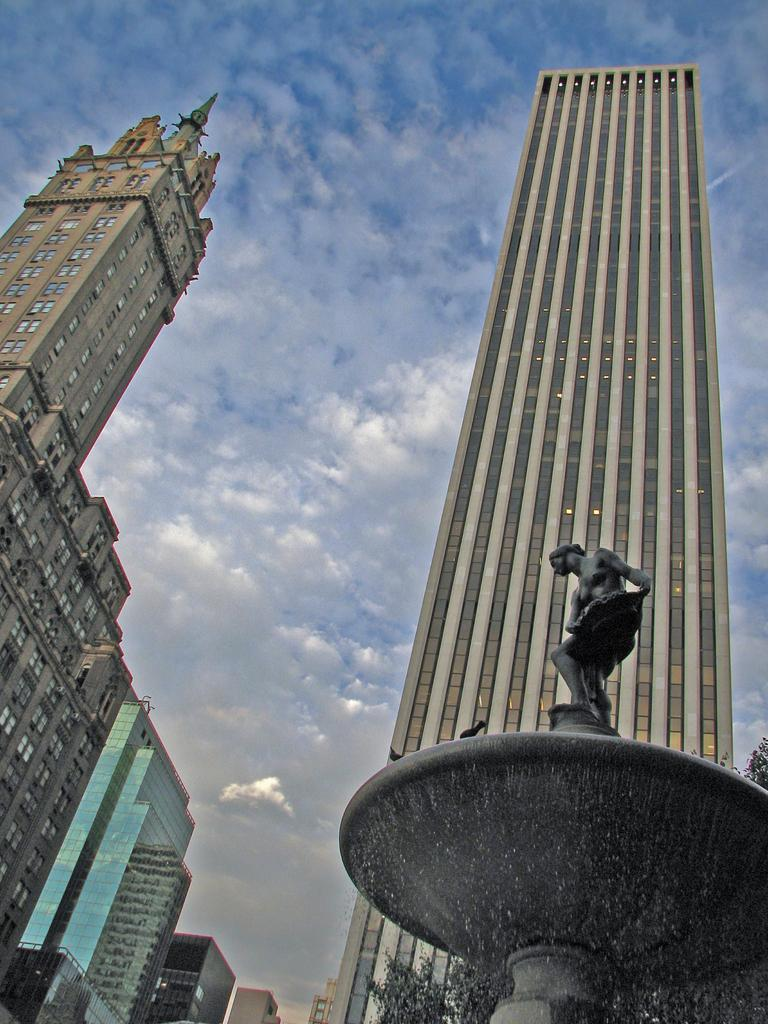What is located on the right side of the image? There is a statue and a water fountain on the right side of the image. What type of structures can be seen in the image? There are buildings visible in the image. What is visible in the background of the image? The sky is visible in the image. What type of crib is visible in the image? There is no crib present in the image. Can you describe the texture of the statue in the image? The provided facts do not mention the texture of the statue, so it cannot be described. 